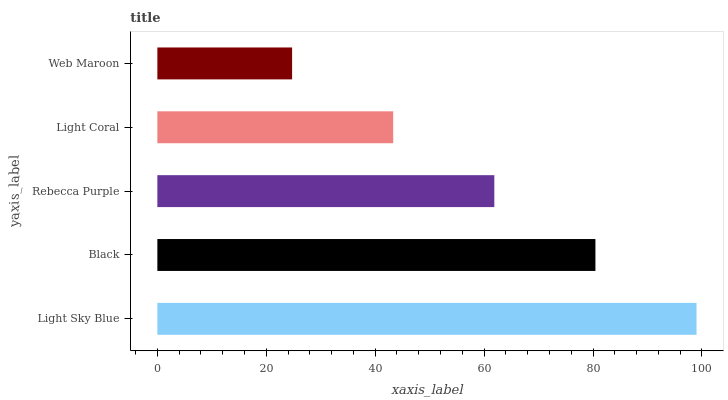Is Web Maroon the minimum?
Answer yes or no. Yes. Is Light Sky Blue the maximum?
Answer yes or no. Yes. Is Black the minimum?
Answer yes or no. No. Is Black the maximum?
Answer yes or no. No. Is Light Sky Blue greater than Black?
Answer yes or no. Yes. Is Black less than Light Sky Blue?
Answer yes or no. Yes. Is Black greater than Light Sky Blue?
Answer yes or no. No. Is Light Sky Blue less than Black?
Answer yes or no. No. Is Rebecca Purple the high median?
Answer yes or no. Yes. Is Rebecca Purple the low median?
Answer yes or no. Yes. Is Web Maroon the high median?
Answer yes or no. No. Is Web Maroon the low median?
Answer yes or no. No. 